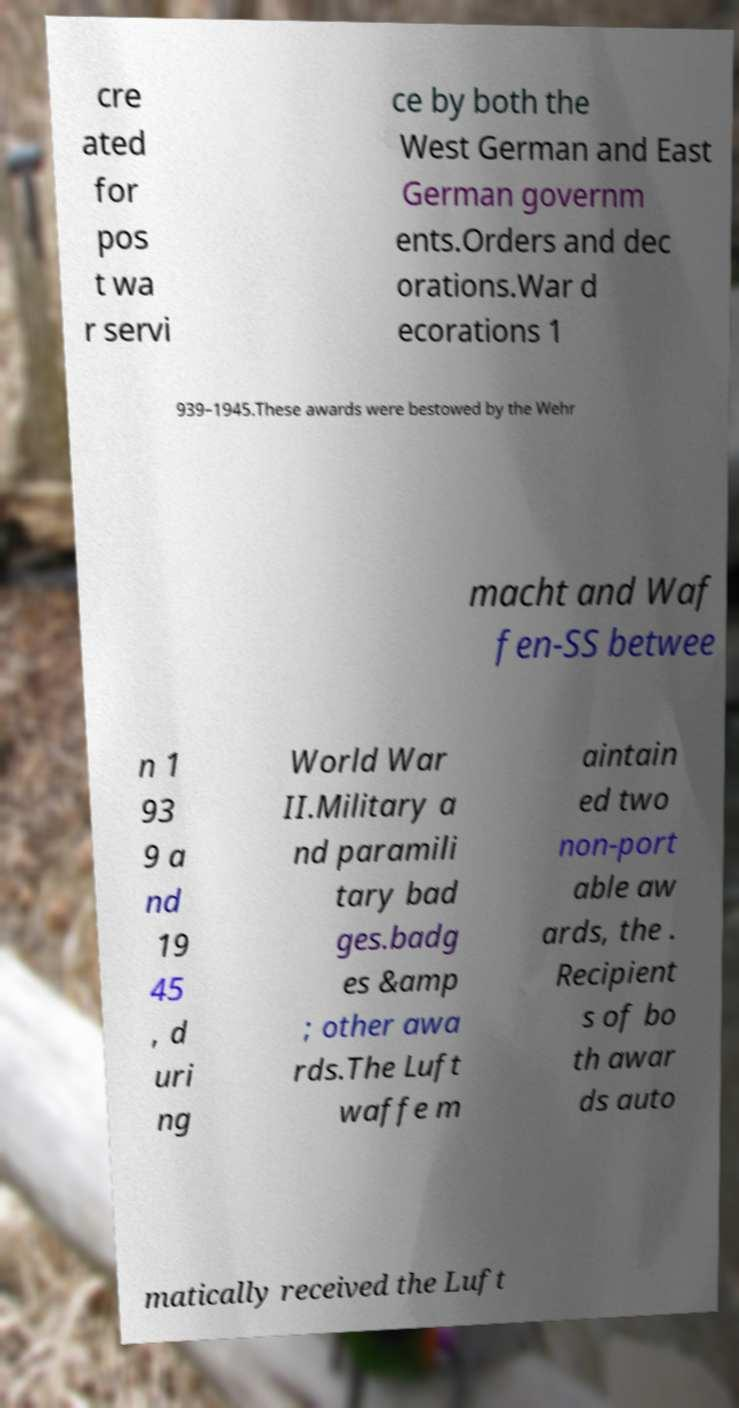Could you assist in decoding the text presented in this image and type it out clearly? cre ated for pos t wa r servi ce by both the West German and East German governm ents.Orders and dec orations.War d ecorations 1 939–1945.These awards were bestowed by the Wehr macht and Waf fen-SS betwee n 1 93 9 a nd 19 45 , d uri ng World War II.Military a nd paramili tary bad ges.badg es &amp ; other awa rds.The Luft waffe m aintain ed two non-port able aw ards, the . Recipient s of bo th awar ds auto matically received the Luft 